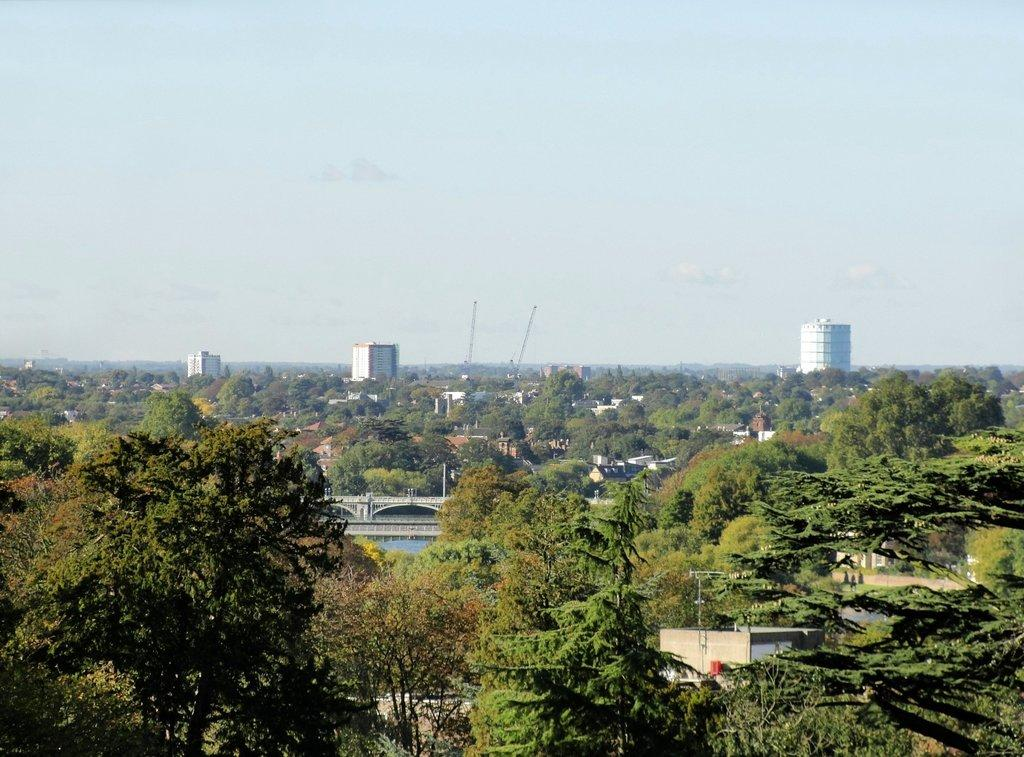What is the primary feature of the landscape in the image? There are many trees in the image. What else can be seen among the trees? There are buildings visible between the trees. What structure is located at the center of the image? There is a bridge at the center of the image. What song is being played in the background of the image? There is no information about any song being played in the image. The image only shows trees, buildings, and a bridge. 